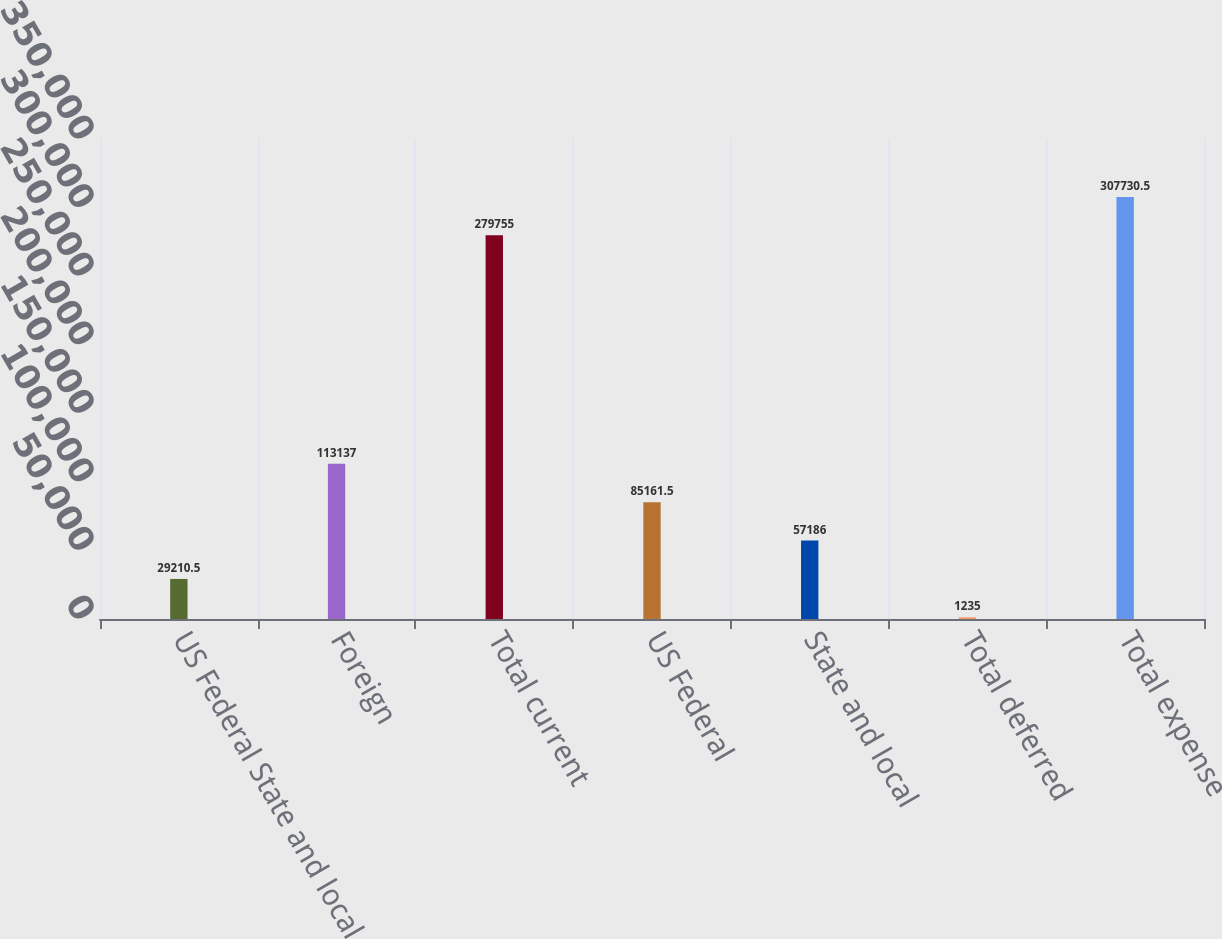Convert chart. <chart><loc_0><loc_0><loc_500><loc_500><bar_chart><fcel>US Federal State and local<fcel>Foreign<fcel>Total current<fcel>US Federal<fcel>State and local<fcel>Total deferred<fcel>Total expense<nl><fcel>29210.5<fcel>113137<fcel>279755<fcel>85161.5<fcel>57186<fcel>1235<fcel>307730<nl></chart> 